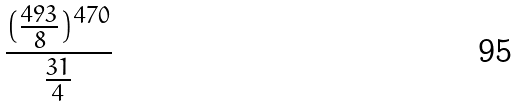<formula> <loc_0><loc_0><loc_500><loc_500>\frac { ( \frac { 4 9 3 } { 8 } ) ^ { 4 7 0 } } { \frac { 3 1 } { 4 } }</formula> 